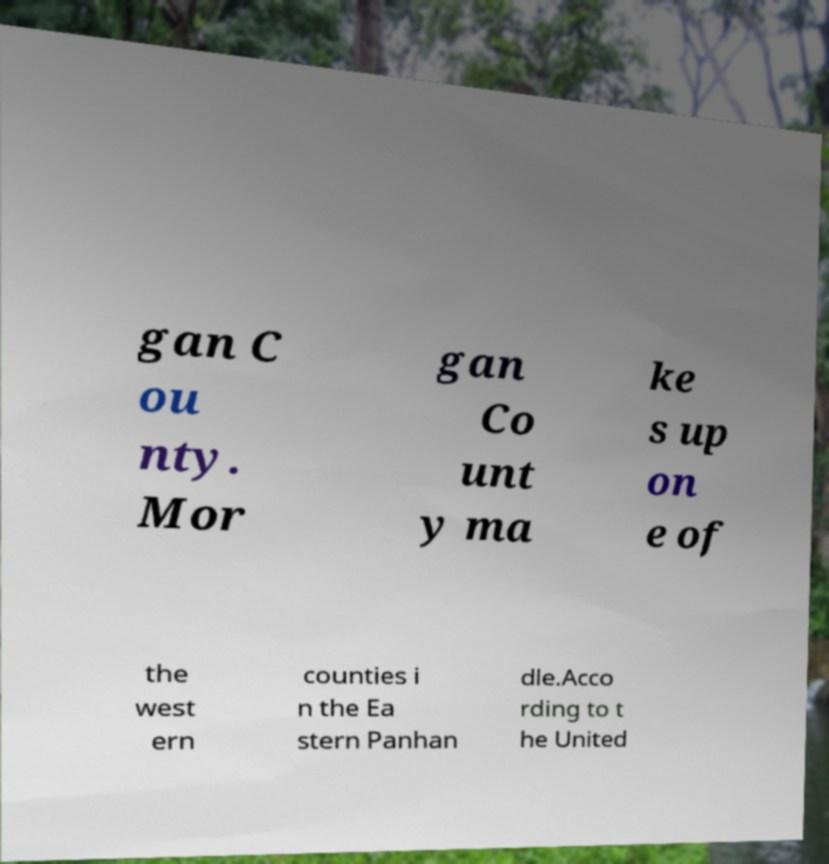Please read and relay the text visible in this image. What does it say? gan C ou nty. Mor gan Co unt y ma ke s up on e of the west ern counties i n the Ea stern Panhan dle.Acco rding to t he United 